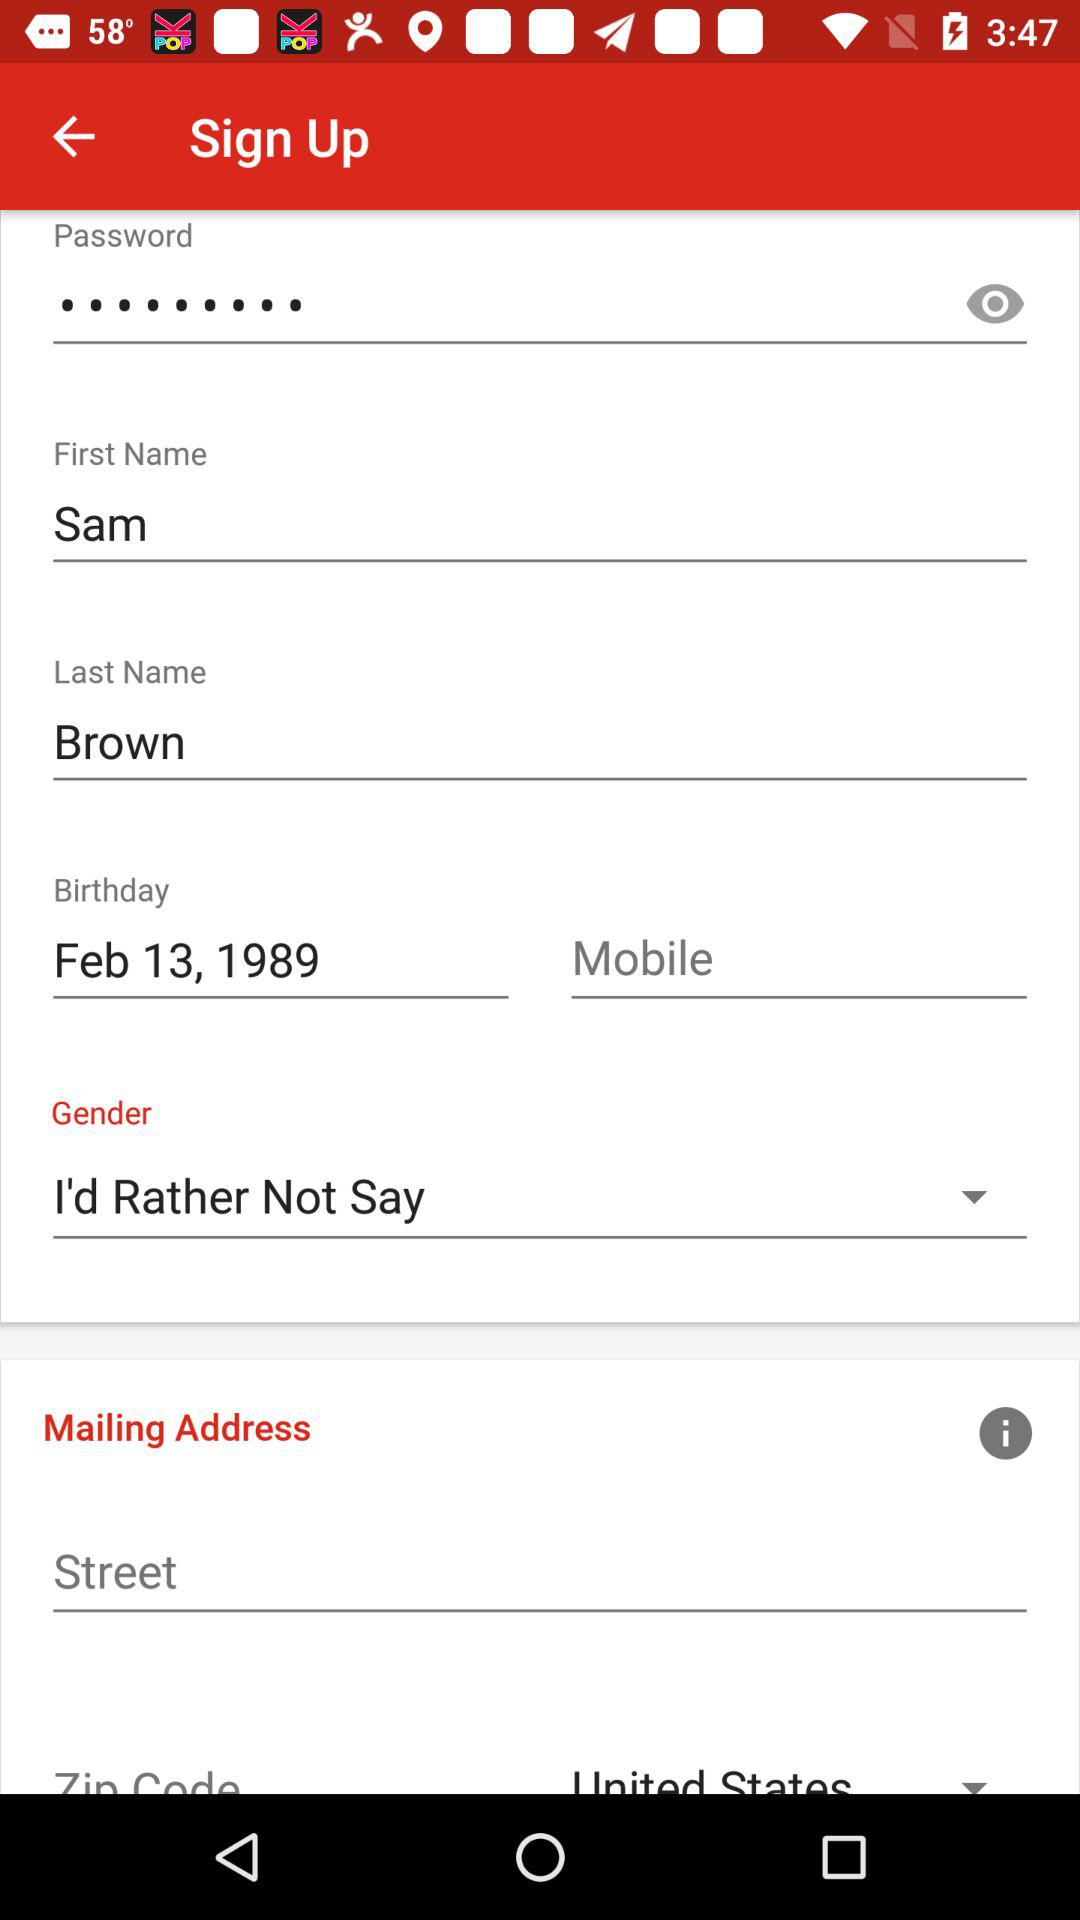What is the mailing address given?
When the provided information is insufficient, respond with <no answer>. <no answer> 